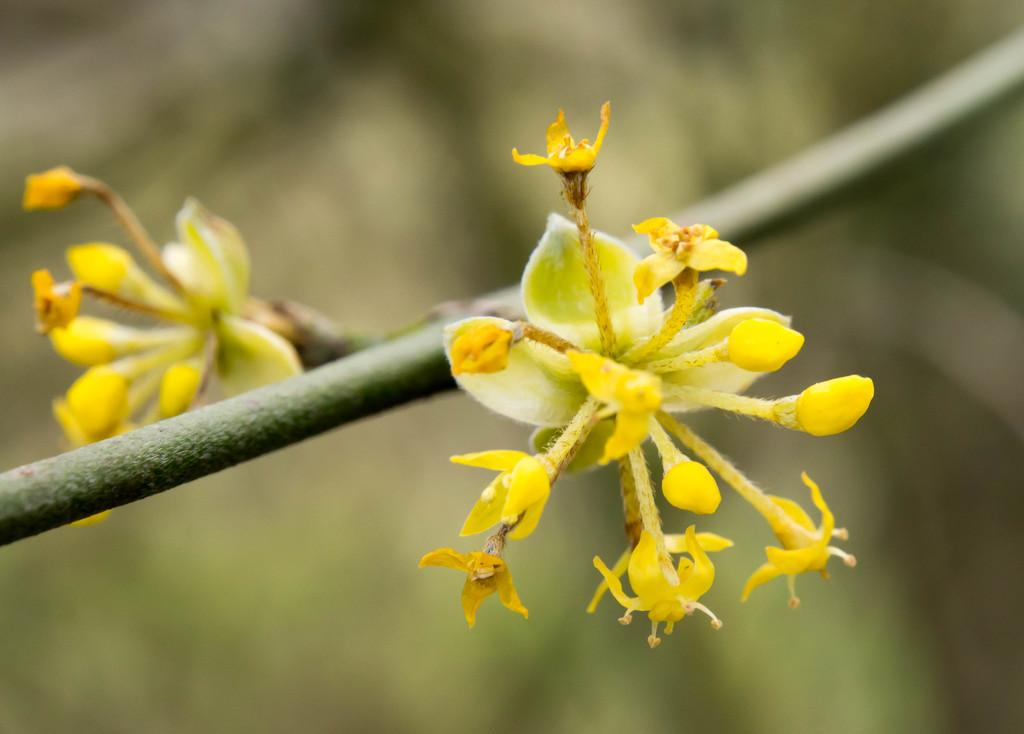What type of plants can be seen in the image? There are flowers in the image. What part of the flowers is visible in the image? The flowers have stems in the image. Can you describe the background of the image? The background of the image is blurry. What type of tail can be seen on the flowers in the image? There are no tails present on the flowers in the image. 